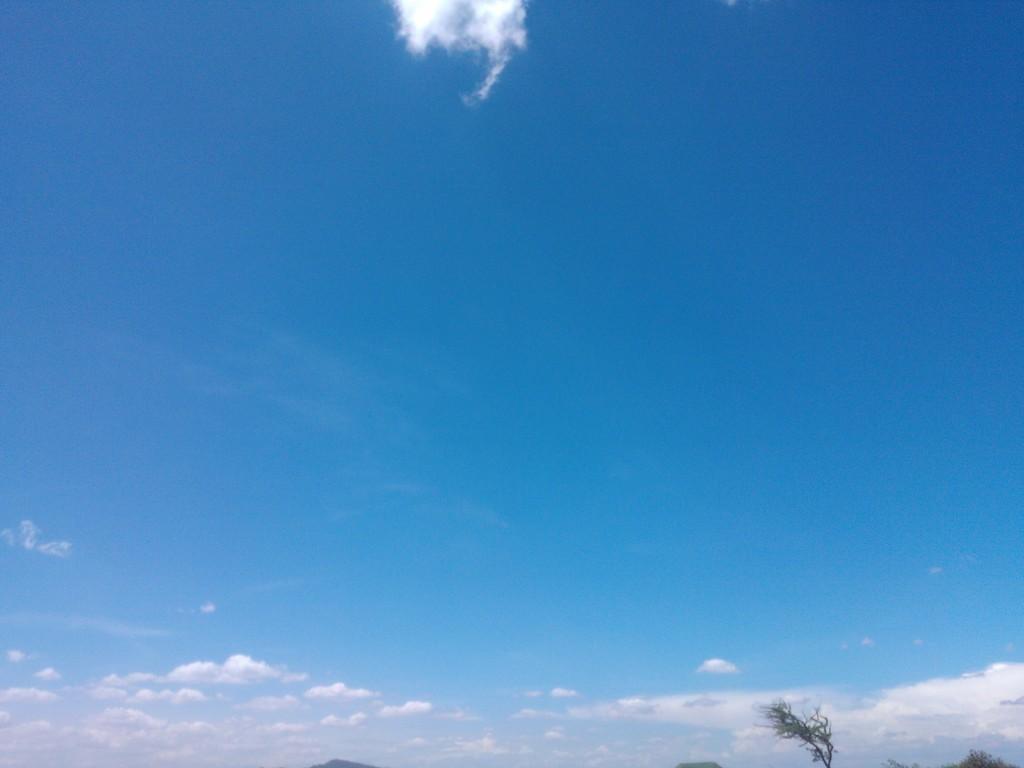Please provide a concise description of this image. In this image I can see few trees in green color. In the background the sky is in blue and white color. 